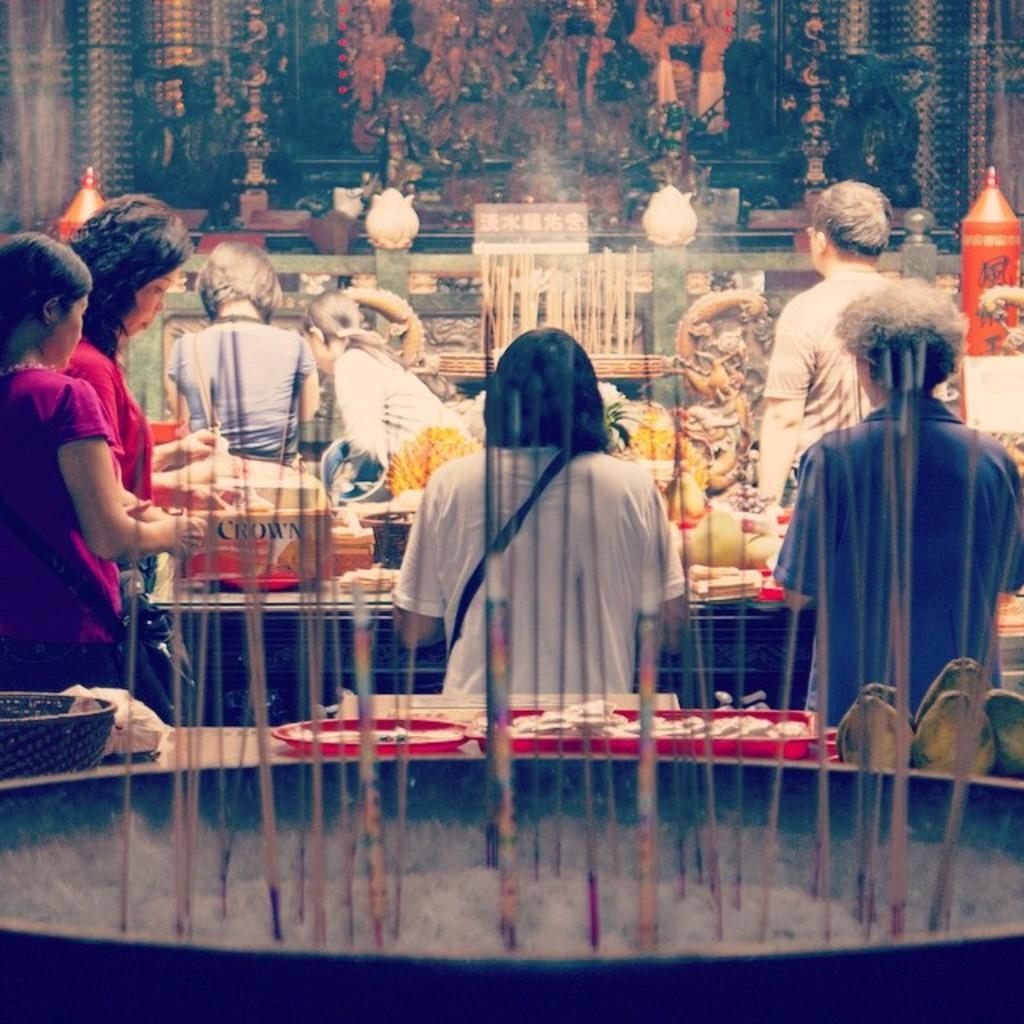Who or what is present in the image? There are people in the image. What else can be seen in the image besides the people? There are many food items in the image. Can you describe the object in the front of the image? There is an object in the front of the image, but its specific details are not mentioned in the facts. What can be seen on the wall in the background of the image? There is a poster on a wall in the background of the image. What type of cave can be seen in the image? There is no cave present in the image. How many dimes are scattered among the food items in the image? There is no mention of dimes in the image, so it cannot be determined how many there are. 